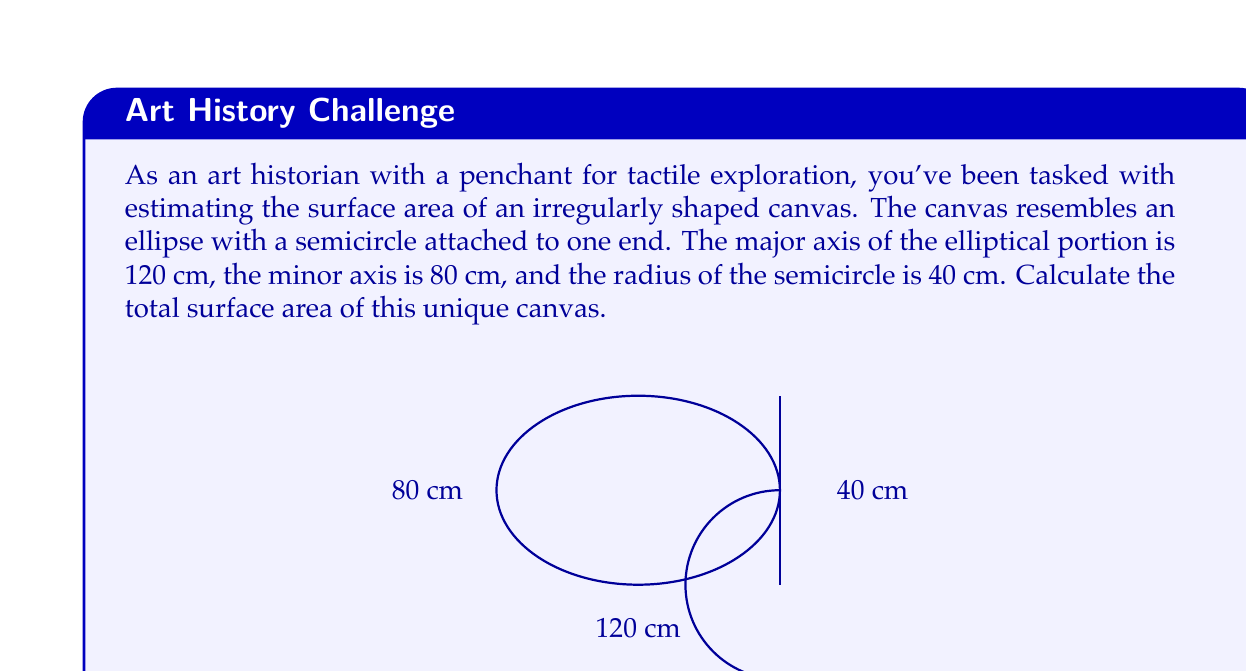Teach me how to tackle this problem. To solve this problem, we need to break it down into two parts: the area of the ellipse and the area of the semicircle.

1. Area of the ellipse:
   The formula for the area of an ellipse is $A_e = \pi ab$, where $a$ and $b$ are the semi-major and semi-minor axes respectively.
   
   $a = 120/2 = 60$ cm
   $b = 80/2 = 40$ cm
   
   $A_e = \pi(60)(40) = 2400\pi$ cm²

2. Area of the semicircle:
   The formula for the area of a semicircle is $A_s = \frac{1}{2}\pi r^2$, where $r$ is the radius.
   
   $r = 40$ cm
   
   $A_s = \frac{1}{2}\pi(40)^2 = 800\pi$ cm²

3. Total surface area:
   The total surface area is the sum of the ellipse area and the semicircle area.
   
   $A_{total} = A_e + A_s = 2400\pi + 800\pi = 3200\pi$ cm²

To get the final numerical value, we can use $\pi \approx 3.14159$:

$A_{total} \approx 3200 * 3.14159 \approx 10053.09$ cm²
Answer: The total surface area of the irregularly shaped canvas is $3200\pi$ cm² or approximately 10053.09 cm². 